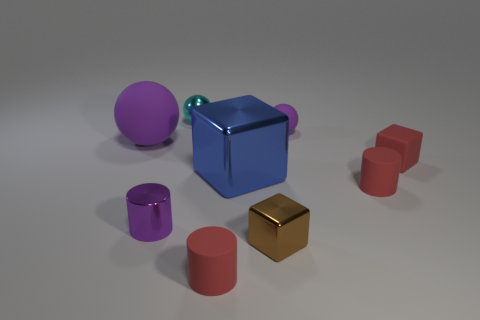Is the size of the shiny object behind the rubber cube the same as the large purple sphere?
Ensure brevity in your answer.  No. How many things are large balls or big blue metallic objects?
Provide a short and direct response. 2. What material is the tiny red cylinder behind the tiny rubber cylinder to the left of the purple matte thing that is to the right of the big matte ball?
Your answer should be compact. Rubber. There is a tiny purple thing that is behind the big ball; what is its material?
Your answer should be very brief. Rubber. Are there any metallic cylinders of the same size as the cyan ball?
Make the answer very short. Yes. Is the color of the tiny cylinder behind the purple cylinder the same as the tiny shiny cylinder?
Offer a terse response. No. What number of red objects are either shiny things or large objects?
Provide a short and direct response. 0. How many tiny cubes are the same color as the shiny ball?
Give a very brief answer. 0. Is the brown block made of the same material as the big purple thing?
Ensure brevity in your answer.  No. There is a small purple thing behind the purple cylinder; how many tiny purple things are in front of it?
Your answer should be very brief. 1. 